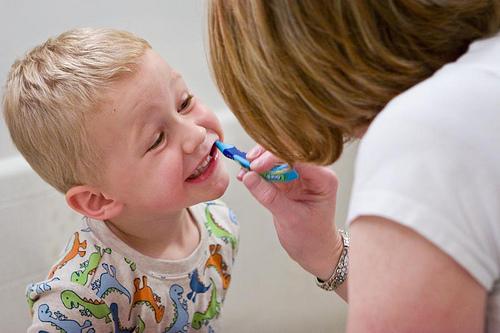Is this a doll?
Short answer required. No. What color is the child's hair?
Quick response, please. Blonde. Is the adult and the baby doing the same task?
Write a very short answer. No. What color shirt is the mom wearing?
Be succinct. White. What device is this woman using?
Answer briefly. Toothbrush. What is the mom doing?
Be succinct. Brushing teeth. 